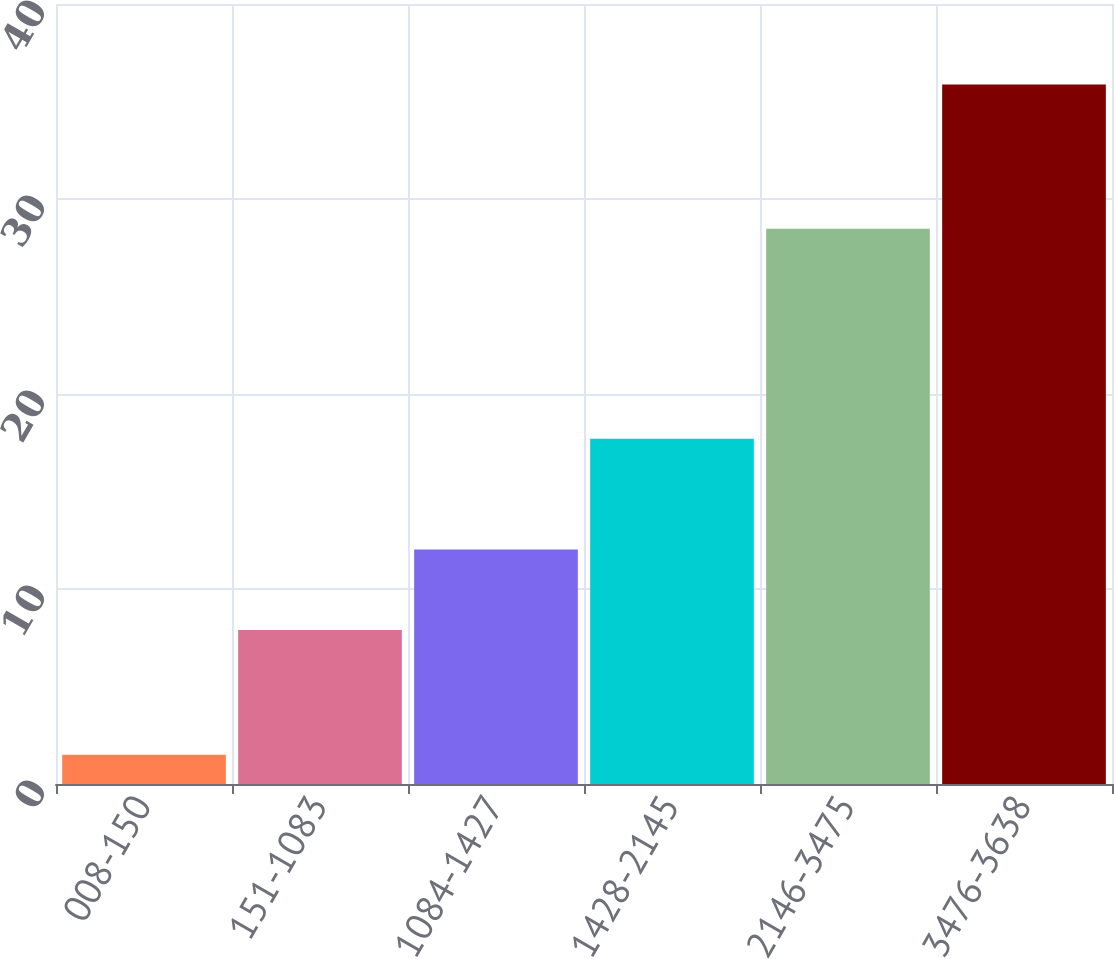Convert chart to OTSL. <chart><loc_0><loc_0><loc_500><loc_500><bar_chart><fcel>008-150<fcel>151-1083<fcel>1084-1427<fcel>1428-2145<fcel>2146-3475<fcel>3476-3638<nl><fcel>1.5<fcel>7.9<fcel>12.03<fcel>17.7<fcel>28.48<fcel>35.87<nl></chart> 